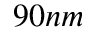<formula> <loc_0><loc_0><loc_500><loc_500>9 0 n m</formula> 